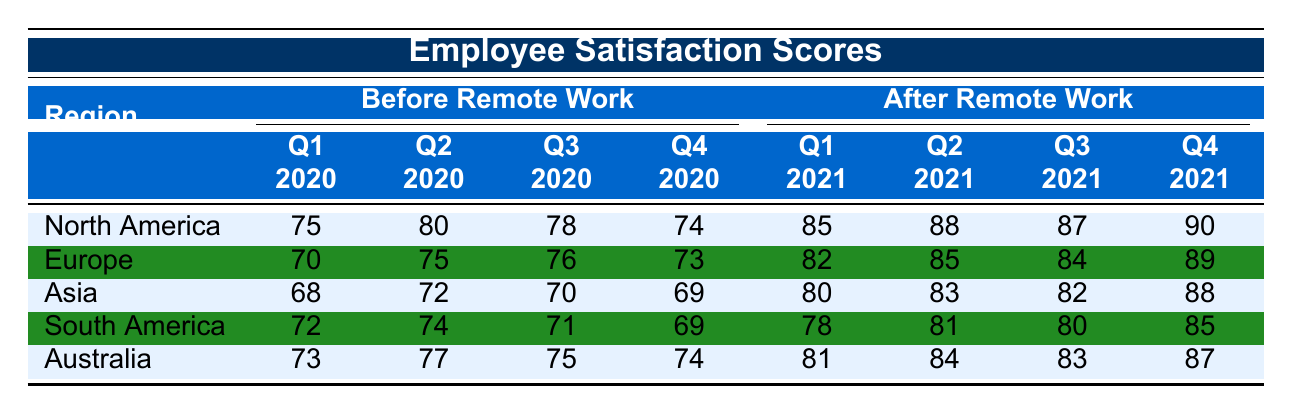What was the Employee Satisfaction Score in North America for Q1 2020? The score for North America in Q1 2020, as shown in the table, is 75.
Answer: 75 What was the highest Employee Satisfaction Score after Remote Work implementation in Australia? After Remote Work implementation, the scores for Australia were Q1 2021: 81, Q2 2021: 84, Q3 2021: 83, Q4 2021: 87. The highest score is 87.
Answer: 87 Which region had the lowest Employee Satisfaction Score before Remote Work implementation? The lowest score before Remote Work implementation was in Asia, which had a score of 68 in Q1 2020.
Answer: Asia What was the average Employee Satisfaction Score for Europe before Remote Work? The scores for Europe before Remote Work were Q1 2020: 70, Q2 2020: 75, Q3 2020: 76, and Q4 2020: 73. The total is 70 + 75 + 76 + 73 = 294, and the average is 294 / 4 = 73.5.
Answer: 73.5 Did Employee Satisfaction Scores increase in South America after Remote Work implementation? Before Remote Work, the highest score in South America was 74 (Q2 2020), and after Remote Work, the highest score was 85 (Q4 2021). Since the scores after Remote Work are all higher than before, the answer is yes.
Answer: Yes What was the difference in Employee Satisfaction Score between Q4 2020 and Q4 2021 for North America? The score for North America in Q4 2020 was 74, and in Q4 2021 it was 90. The difference is 90 - 74 = 16.
Answer: 16 Which region showed the greatest improvement in Employee Satisfaction Scores from before to after Remote Work? The improvements are: North America: 15 points, Europe: 16 points, Asia: 20 points, South America: 16 points, Australia: 13 points. The greatest improvement was in Asia with 20 points.
Answer: Asia What was the overall trend in Employee Satisfaction Scores for all regions after Remote Work implementation? All regions showed an increase in scores after Remote Work implementation compared to before, indicating a positive trend overall.
Answer: Increase What was the total Employee Satisfaction Score for all regions in Q2 2021 after Remote Work? In Q2 2021, the scores were: North America: 88, Europe: 85, Asia: 83, South America: 81, Australia: 84. The total is 88 + 85 + 83 + 81 + 84 = 421.
Answer: 421 Which region had the highest Employee Satisfaction Score before Remote Work implementation? The scores before Remote Work were: North America: 80, Europe: 75, Asia: 72, South America: 74, Australia: 77. The highest score was 80 in North America.
Answer: North America 